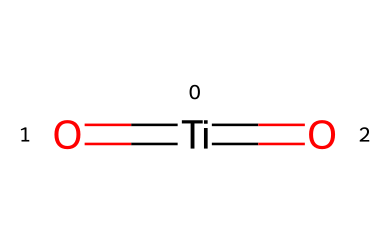What is the central atom in this chemical structure? The central atom is titanium, as indicated by the presence of the Ti symbol in the structure.
Answer: titanium How many oxygen atoms are present in this chemical? The structure indicates two oxygen atoms, represented by the O connected to the titanium through double bonds.
Answer: 2 What type of bonding is present between titanium and oxygen in this compound? The bonding between titanium and oxygen is double bonding, as demonstrated by the '=' signs in the SMILES representation.
Answer: double bonds What is the oxidation state of titanium in this compound? The oxidation state of titanium can be determined by considering that it forms double bonds with two oxygen atoms, which typically suggests a +4 oxidation state.
Answer: +4 Is titanium dioxide a photocatalyst? Yes, titanium dioxide is known to function as a photocatalyst due to its ability to absorb UV light and facilitate chemical reactions.
Answer: yes What role does titanium dioxide play in self-cleaning glass? Titanium dioxide serves as a photocatalyst that, when activated by sunlight, generates reactive species that break down organic dirt and contaminants, making the glass self-cleaning.
Answer: photocatalyst 